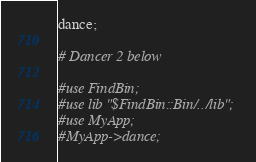<code> <loc_0><loc_0><loc_500><loc_500><_Perl_>dance;

# Dancer 2 below

#use FindBin;
#use lib "$FindBin::Bin/../lib";
#use MyApp;
#MyApp->dance;</code> 